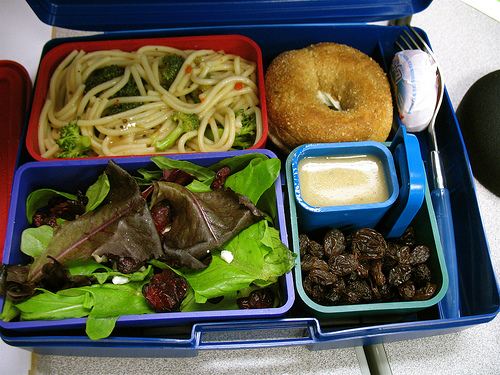<image>
Can you confirm if the raisins is in front of the bagel? Yes. The raisins is positioned in front of the bagel, appearing closer to the camera viewpoint. Is there a donut in front of the dip? No. The donut is not in front of the dip. The spatial positioning shows a different relationship between these objects. 